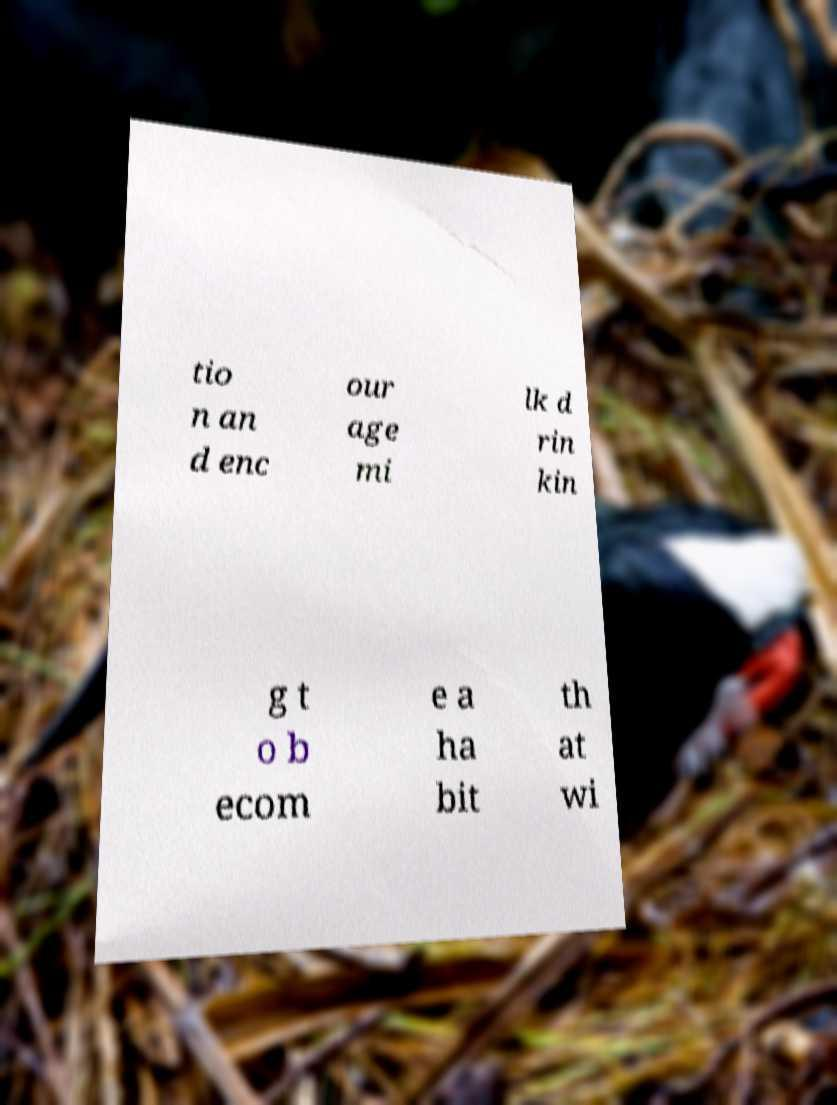Could you extract and type out the text from this image? tio n an d enc our age mi lk d rin kin g t o b ecom e a ha bit th at wi 